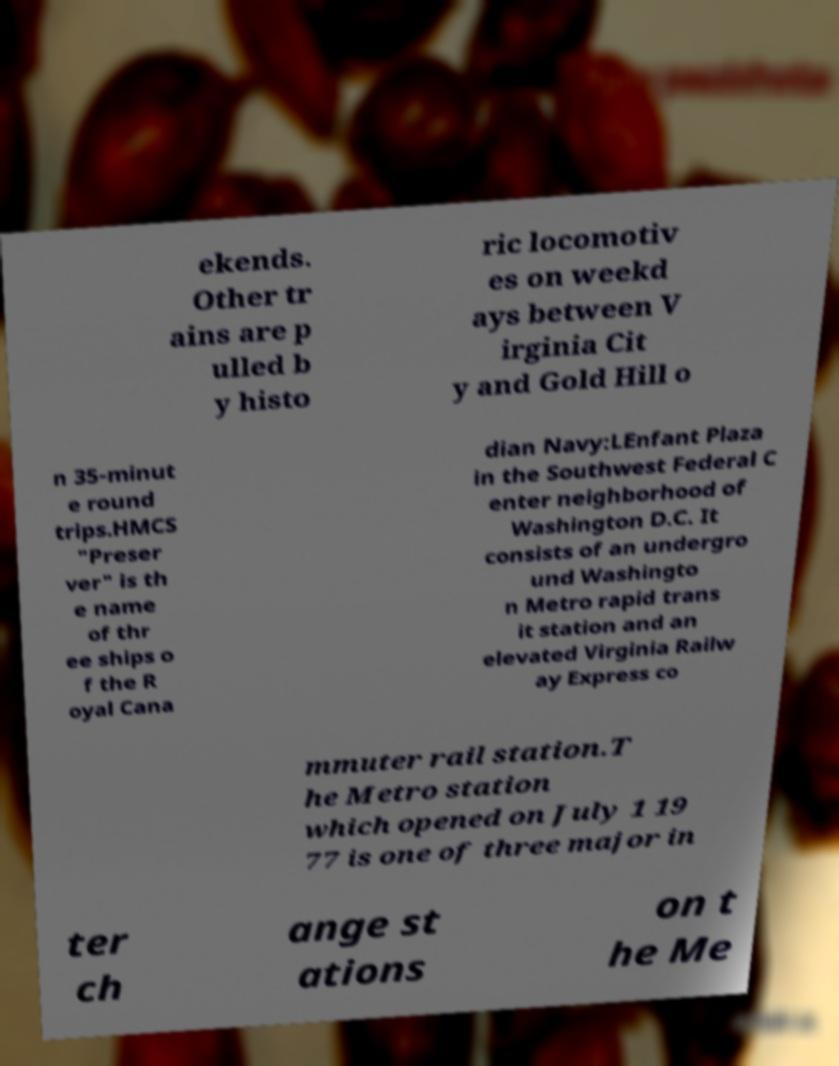Please read and relay the text visible in this image. What does it say? ekends. Other tr ains are p ulled b y histo ric locomotiv es on weekd ays between V irginia Cit y and Gold Hill o n 35-minut e round trips.HMCS "Preser ver" is th e name of thr ee ships o f the R oyal Cana dian Navy:LEnfant Plaza in the Southwest Federal C enter neighborhood of Washington D.C. It consists of an undergro und Washingto n Metro rapid trans it station and an elevated Virginia Railw ay Express co mmuter rail station.T he Metro station which opened on July 1 19 77 is one of three major in ter ch ange st ations on t he Me 